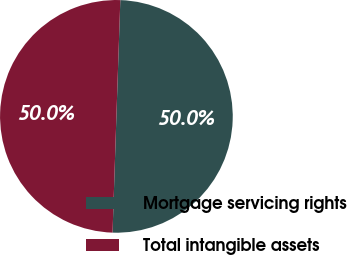Convert chart. <chart><loc_0><loc_0><loc_500><loc_500><pie_chart><fcel>Mortgage servicing rights<fcel>Total intangible assets<nl><fcel>49.99%<fcel>50.01%<nl></chart> 